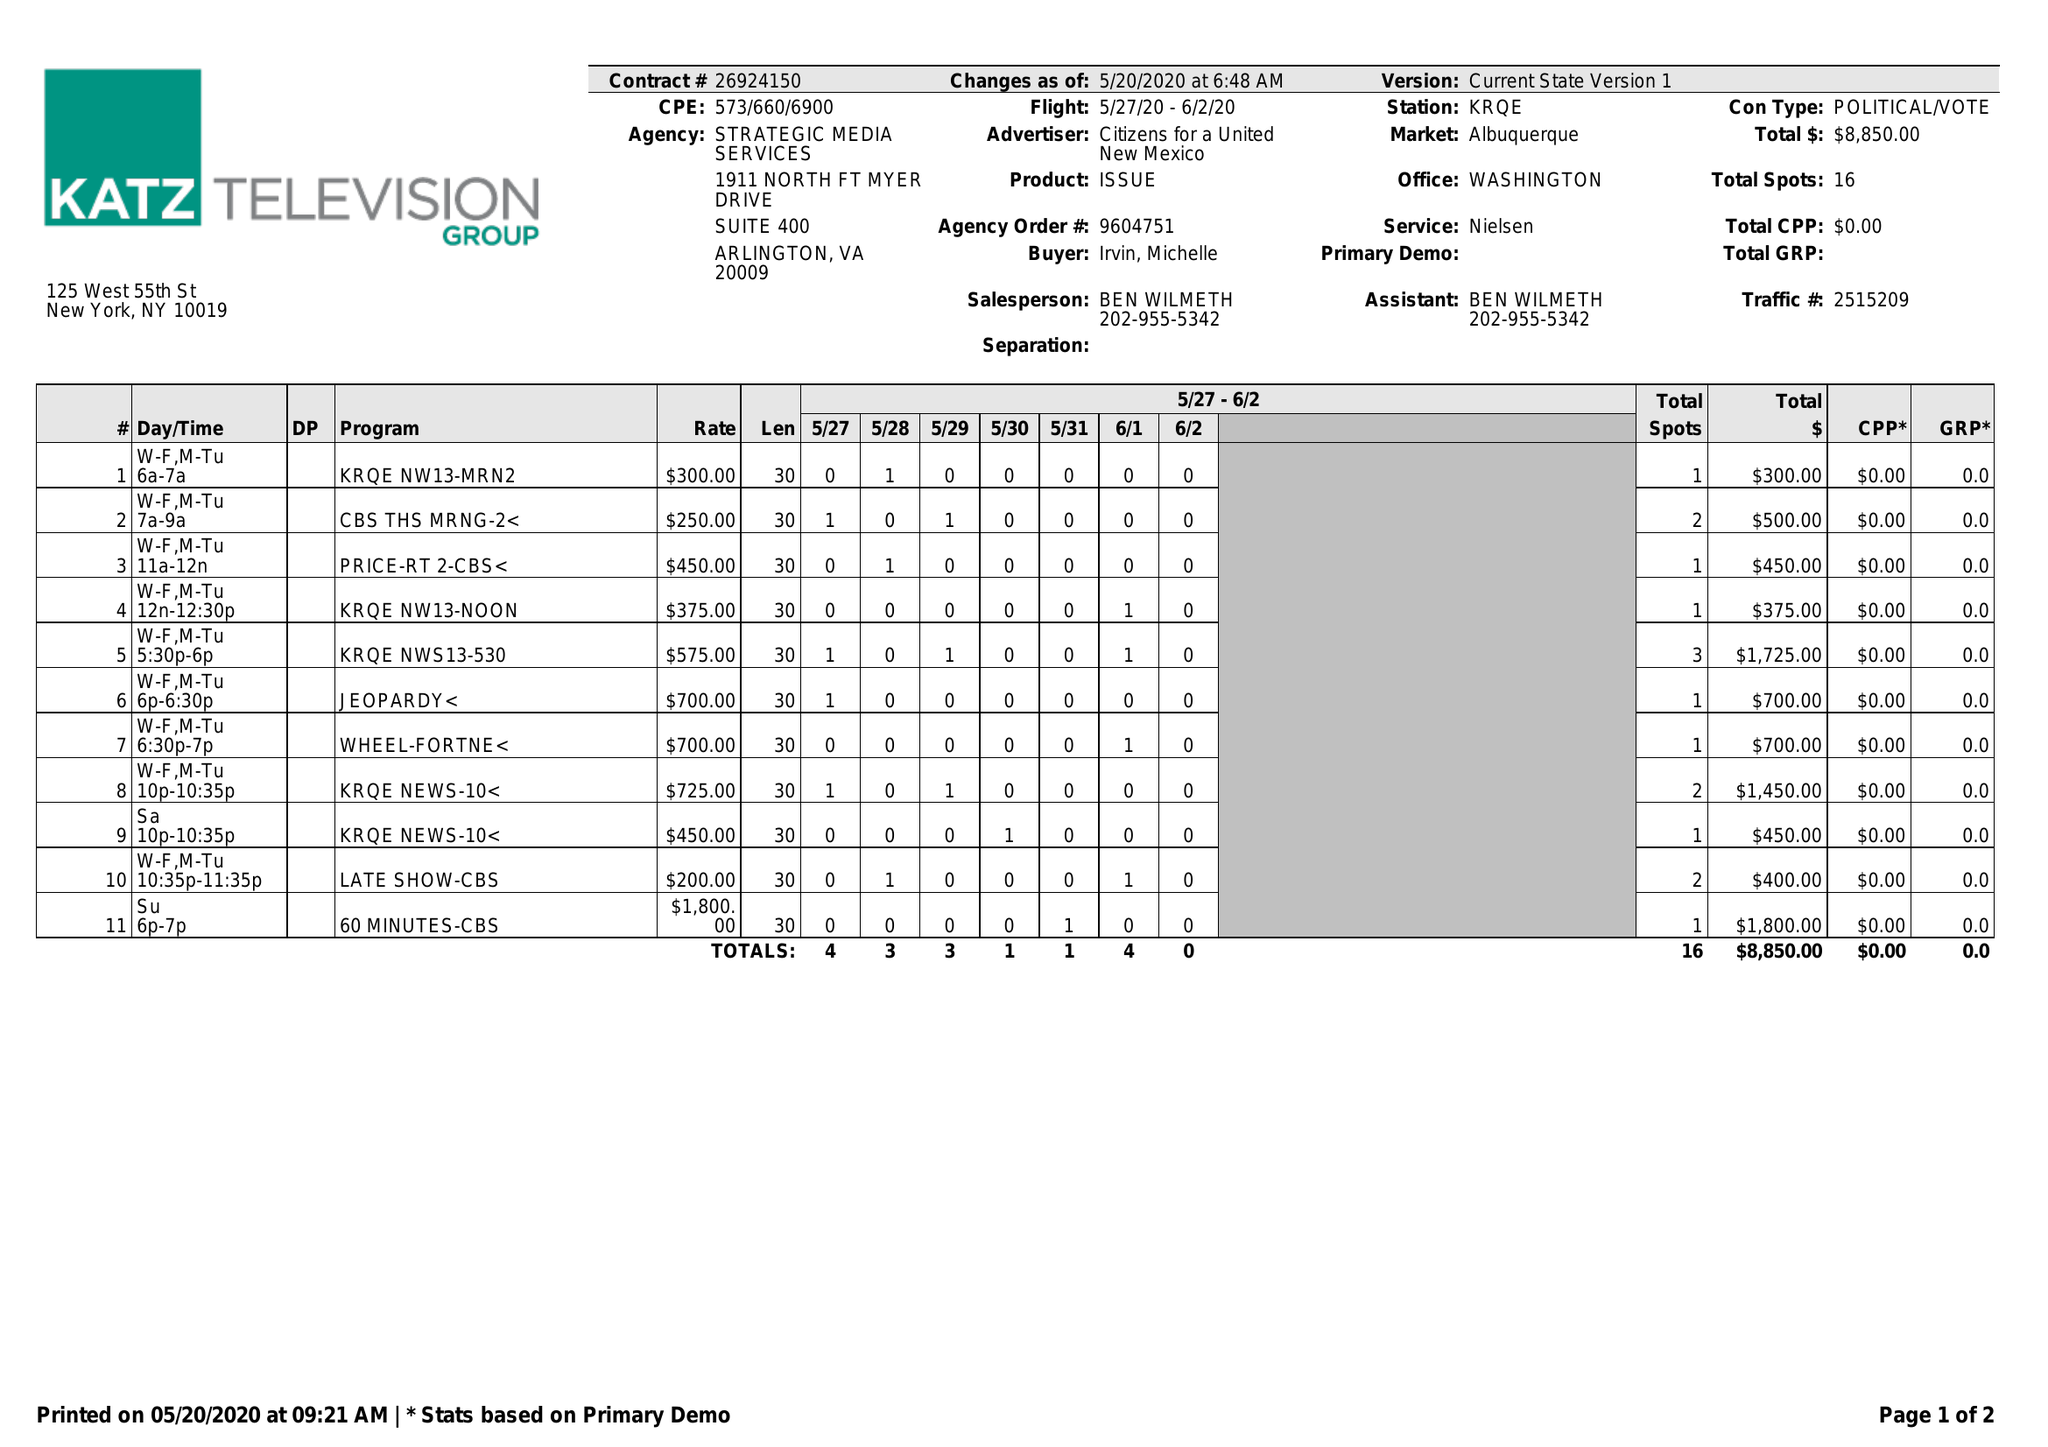What is the value for the advertiser?
Answer the question using a single word or phrase. CITIZENS FOR A UNITED NEW MEXICO 